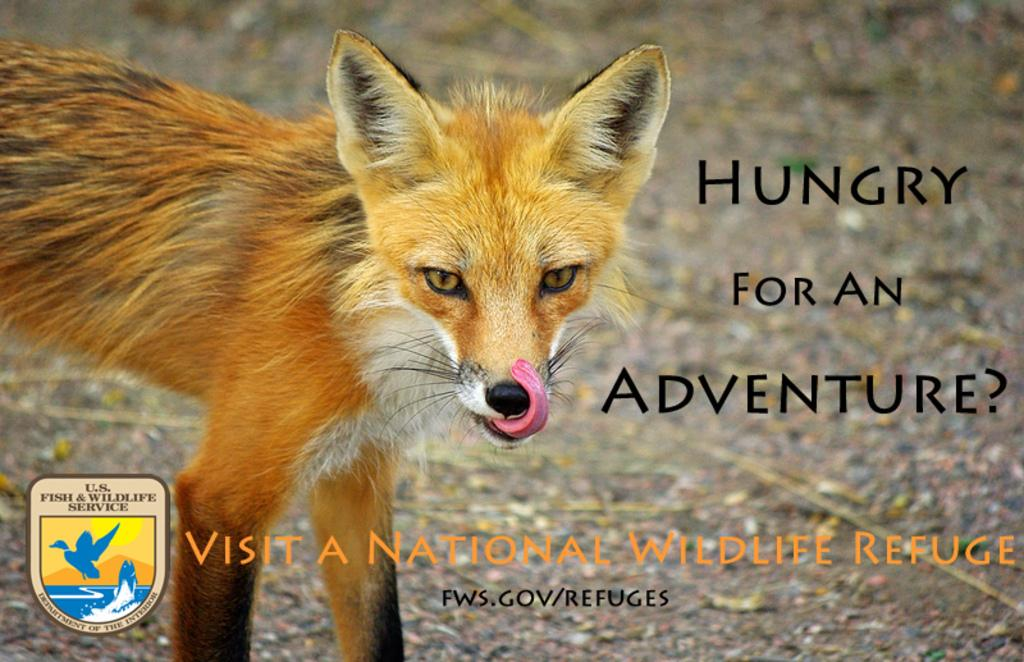What type of animal is present in the image? There is an animal in the image, but its specific type cannot be determined from the provided facts. What else can be seen in the image besides the animal? There is a logo in the image. Can you describe the logo? The logo has text written on it. How does the animal interact with the nerve in the image? There is no nerve present in the image, so it is not possible to determine how the animal interacts with it. 